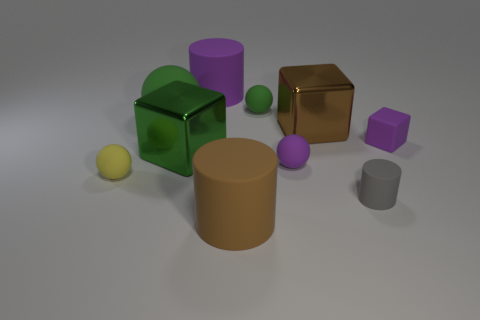Is there any other thing that has the same color as the big sphere?
Make the answer very short. Yes. There is a large cube to the right of the big green block; what number of cylinders are behind it?
Give a very brief answer. 1. Are there any yellow matte objects of the same shape as the small gray thing?
Offer a very short reply. No. Does the brown object that is behind the tiny yellow sphere have the same shape as the big matte thing that is right of the purple matte cylinder?
Your answer should be compact. No. What is the shape of the thing that is both in front of the yellow rubber sphere and on the left side of the gray cylinder?
Provide a succinct answer. Cylinder. Is there another sphere of the same size as the purple sphere?
Provide a succinct answer. Yes. There is a rubber cube; is it the same color as the metal thing behind the purple rubber block?
Offer a very short reply. No. What is the material of the purple cylinder?
Your response must be concise. Rubber. The big matte thing on the left side of the big purple cylinder is what color?
Offer a terse response. Green. How many big things have the same color as the large matte sphere?
Make the answer very short. 1. 